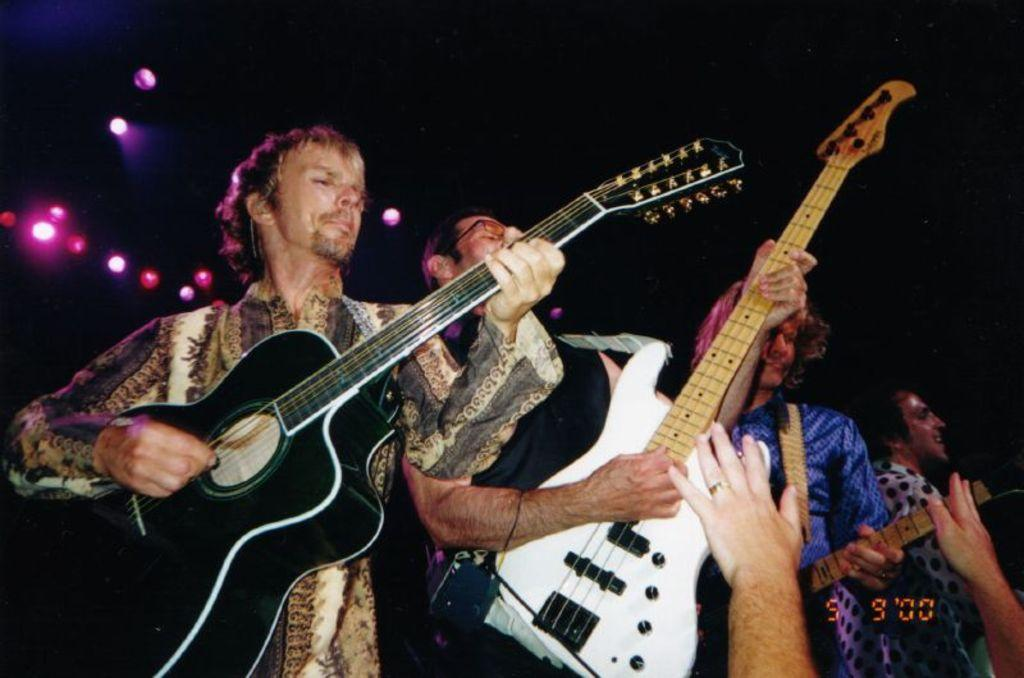How many people are in the image? There are four men in the image. What are the men doing in the image? Each man is holding a guitar and playing it. What can be seen in the background of the image? There are lights visible in the background. How would you describe the lighting conditions in the image? The image appears to be set in a dark environment. What is the weight of the sidewalk in the image? There is no sidewalk present in the image, so it is not possible to determine its weight. 